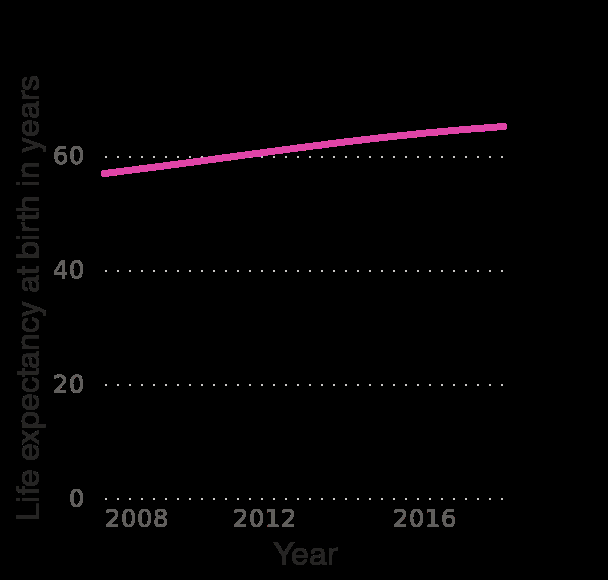<image>
Is life expectancy increasing significantly?  No, it is not increasing significantly. Is the line graph representing the change in life expectancy at birth over time? Yes, the line graph represents the change in life expectancy at birth from 2008 to 2018. 